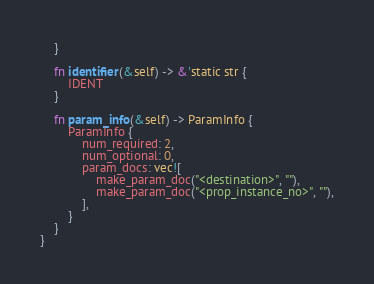<code> <loc_0><loc_0><loc_500><loc_500><_Rust_>    }

    fn identifier(&self) -> &'static str {
        IDENT
    }

    fn param_info(&self) -> ParamInfo {
        ParamInfo {
            num_required: 2,
            num_optional: 0,
            param_docs: vec![
                make_param_doc("<destination>", ""),
                make_param_doc("<prop_instance_no>", ""),
            ],
        }
    }
}
</code> 